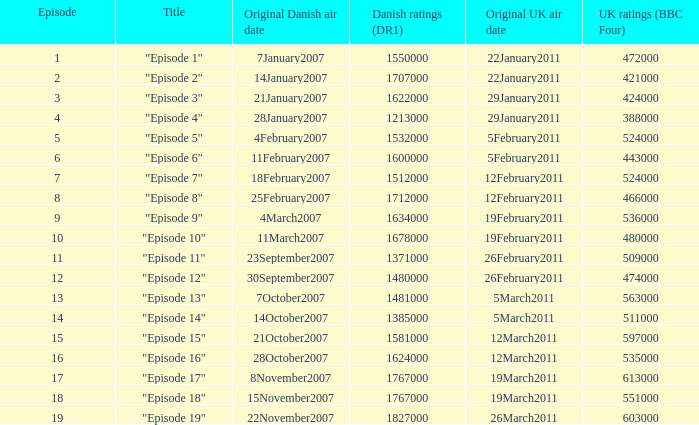What is the initial danish airing date of "episode 17"? 8November2007. 